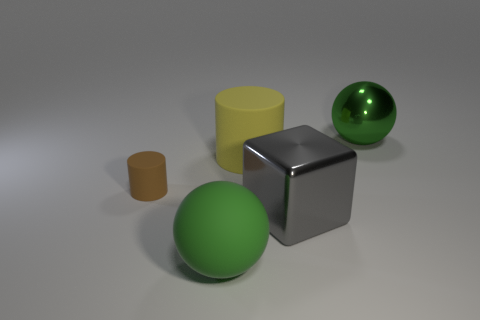Subtract all cubes. How many objects are left? 4 Add 1 large cylinders. How many objects exist? 6 Subtract 1 cylinders. How many cylinders are left? 1 Add 5 yellow rubber things. How many yellow rubber things exist? 6 Subtract all brown cylinders. How many cylinders are left? 1 Subtract 0 purple spheres. How many objects are left? 5 Subtract all yellow spheres. Subtract all red cylinders. How many spheres are left? 2 Subtract all green balls. How many yellow cylinders are left? 1 Subtract all small cylinders. Subtract all green rubber objects. How many objects are left? 3 Add 1 big things. How many big things are left? 5 